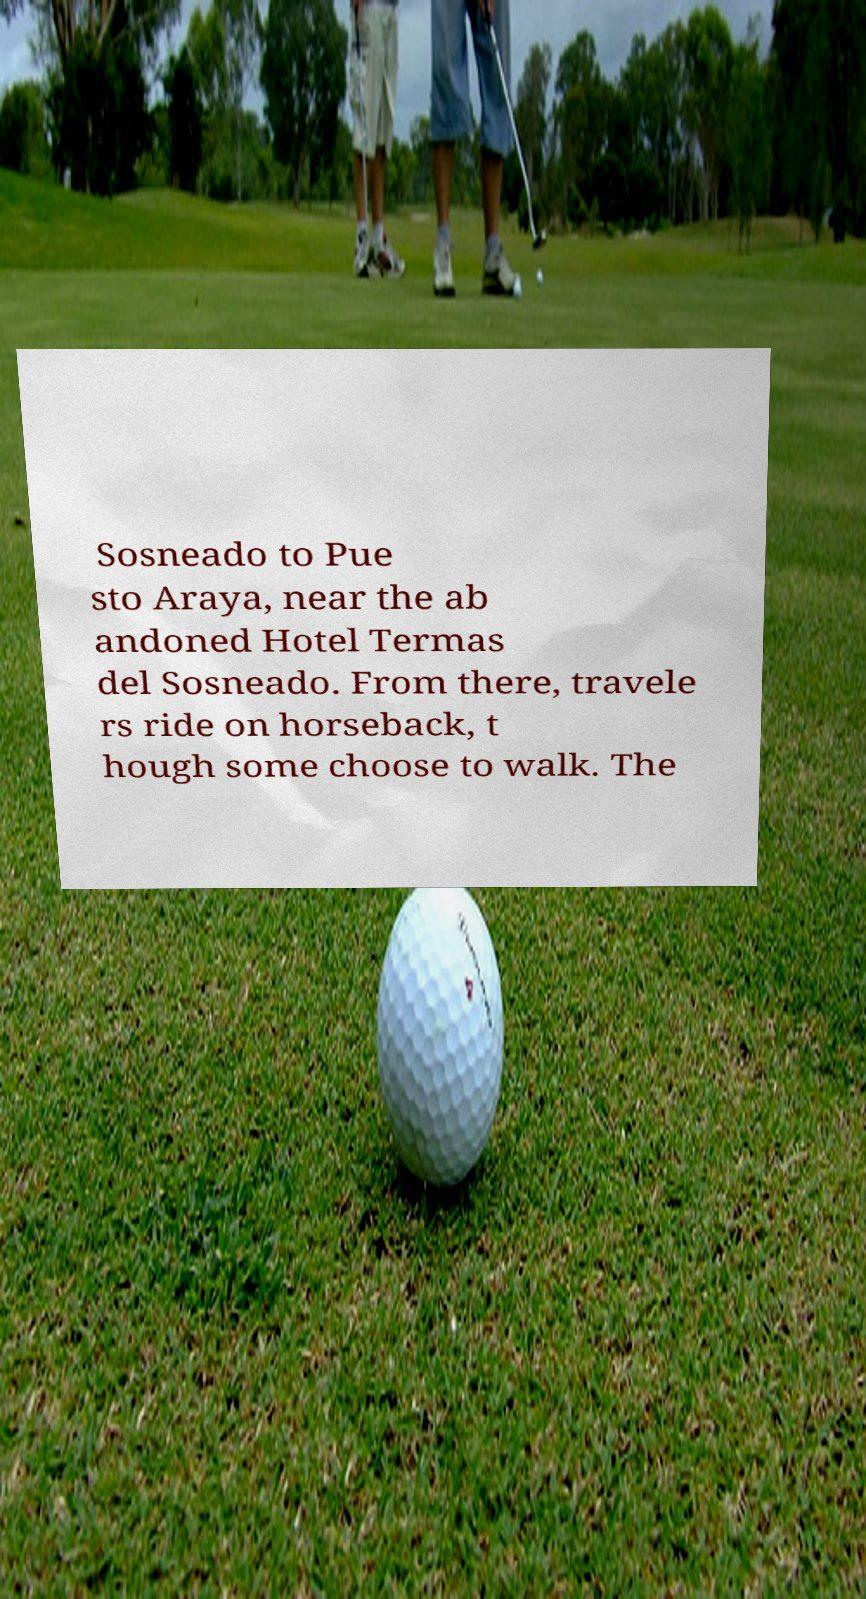Could you assist in decoding the text presented in this image and type it out clearly? Sosneado to Pue sto Araya, near the ab andoned Hotel Termas del Sosneado. From there, travele rs ride on horseback, t hough some choose to walk. The 